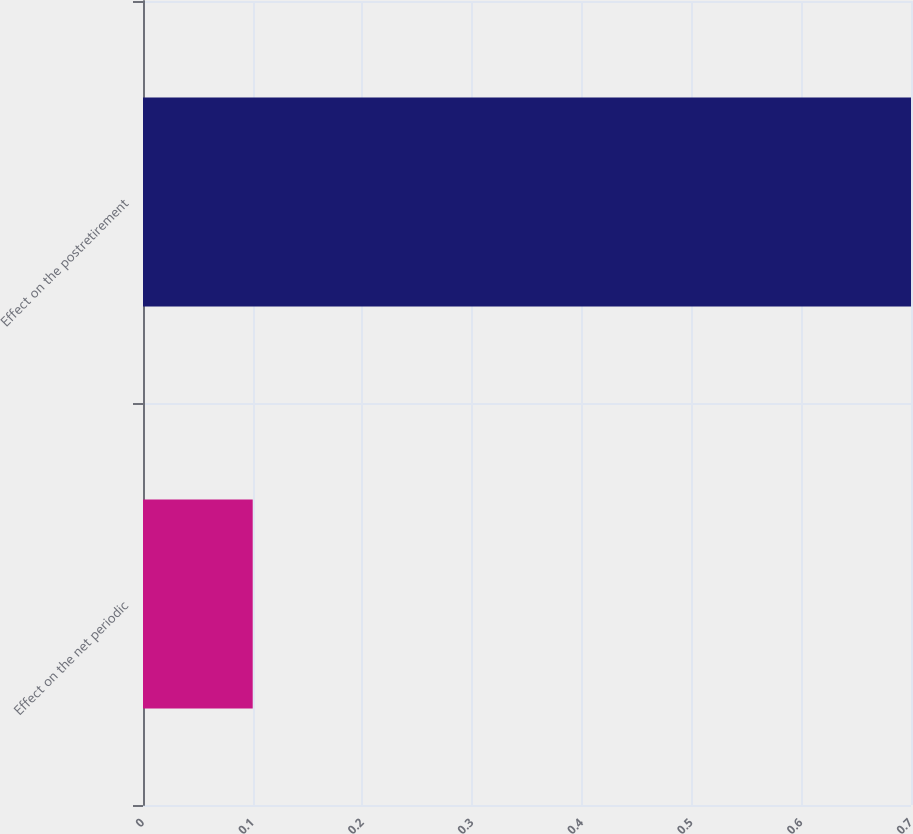Convert chart to OTSL. <chart><loc_0><loc_0><loc_500><loc_500><bar_chart><fcel>Effect on the net periodic<fcel>Effect on the postretirement<nl><fcel>0.1<fcel>0.7<nl></chart> 